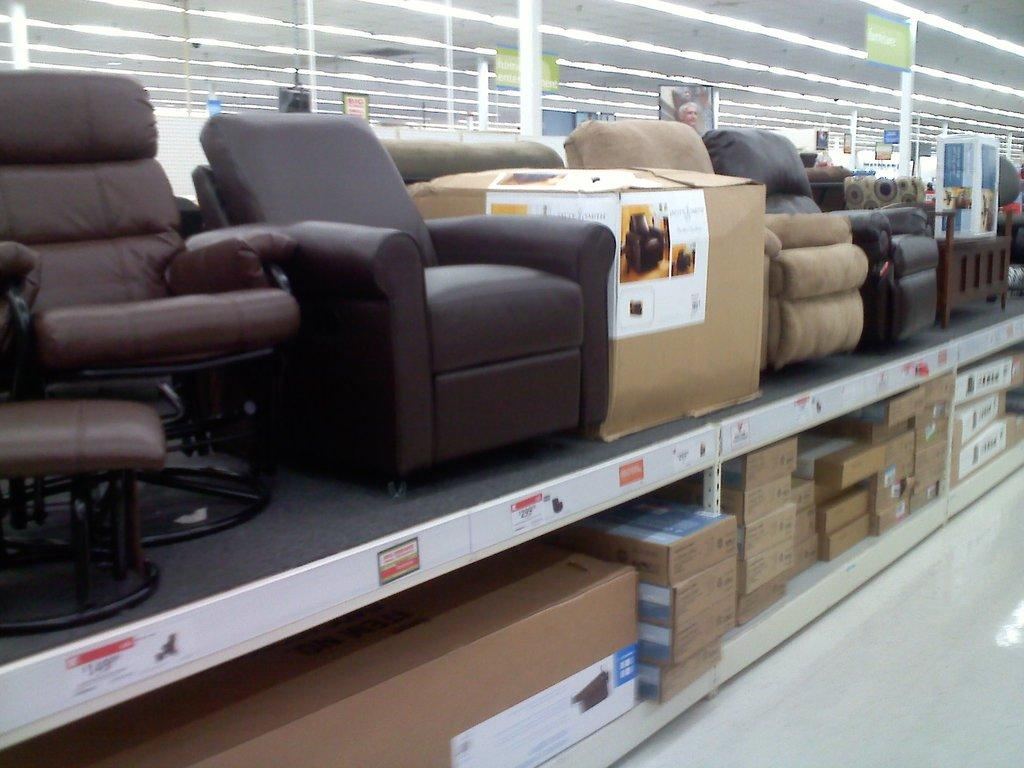What type of furniture is present in the image? There are chairs in the image. What other objects can be seen in the image? There are cardboard boxes, cards, lights, and stickers in the image. What is the plot of the story unfolding in the image? There is no story or plot depicted in the image; it simply shows chairs, cardboard boxes, cards, lights, and stickers. 